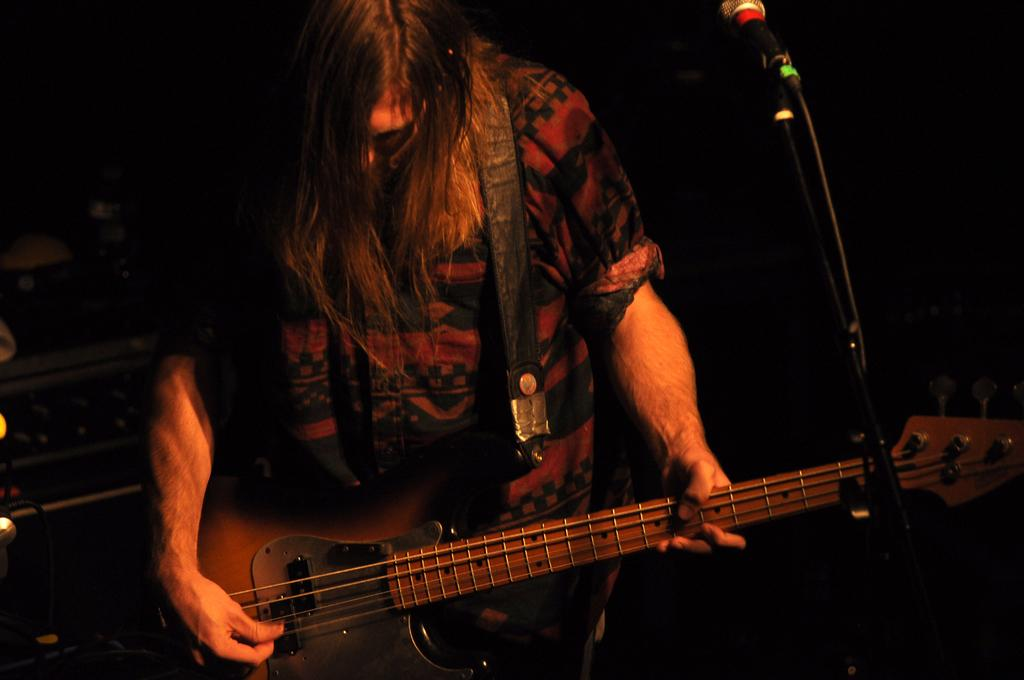What is the man in the image doing? The man is playing a guitar. What object is present in the image that is typically used for amplifying sound? There is a mic in the image. Can you see any boats in the image? There are no boats visible in the image. What type of grass is growing in the image? There is no grass present in the image. 